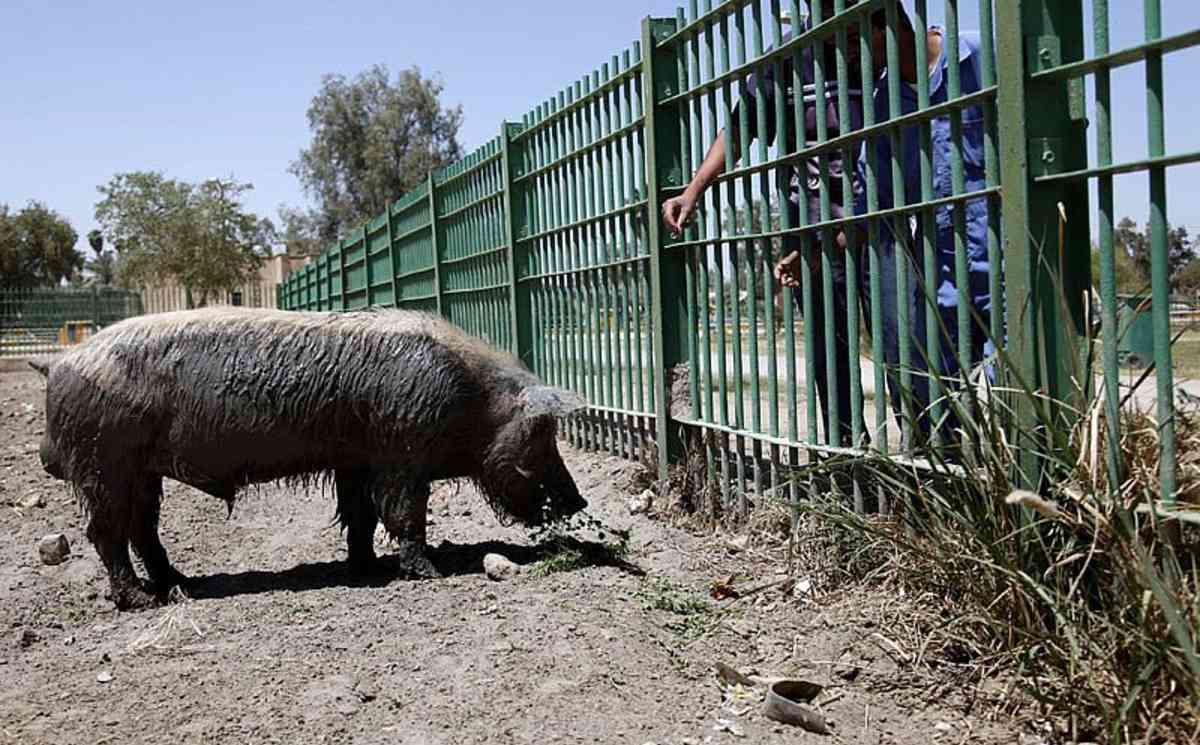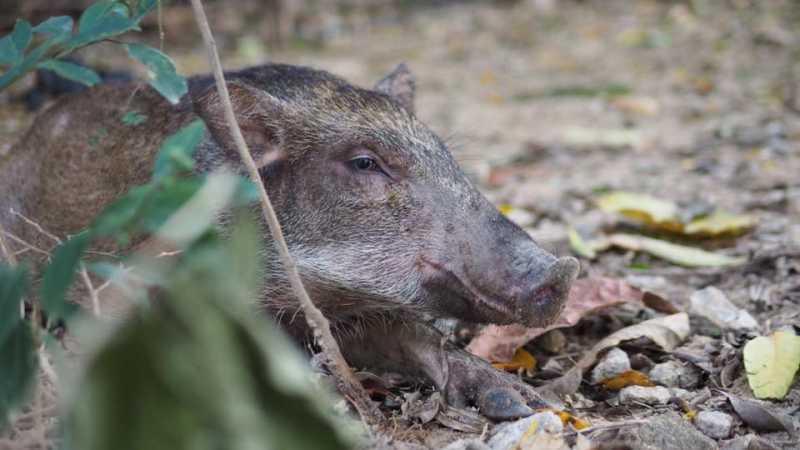The first image is the image on the left, the second image is the image on the right. For the images shown, is this caption "There is a human feeding one of the pigs." true? Answer yes or no. Yes. The first image is the image on the left, the second image is the image on the right. Assess this claim about the two images: "There is at least one image in which there is a person near the boar.". Correct or not? Answer yes or no. Yes. 